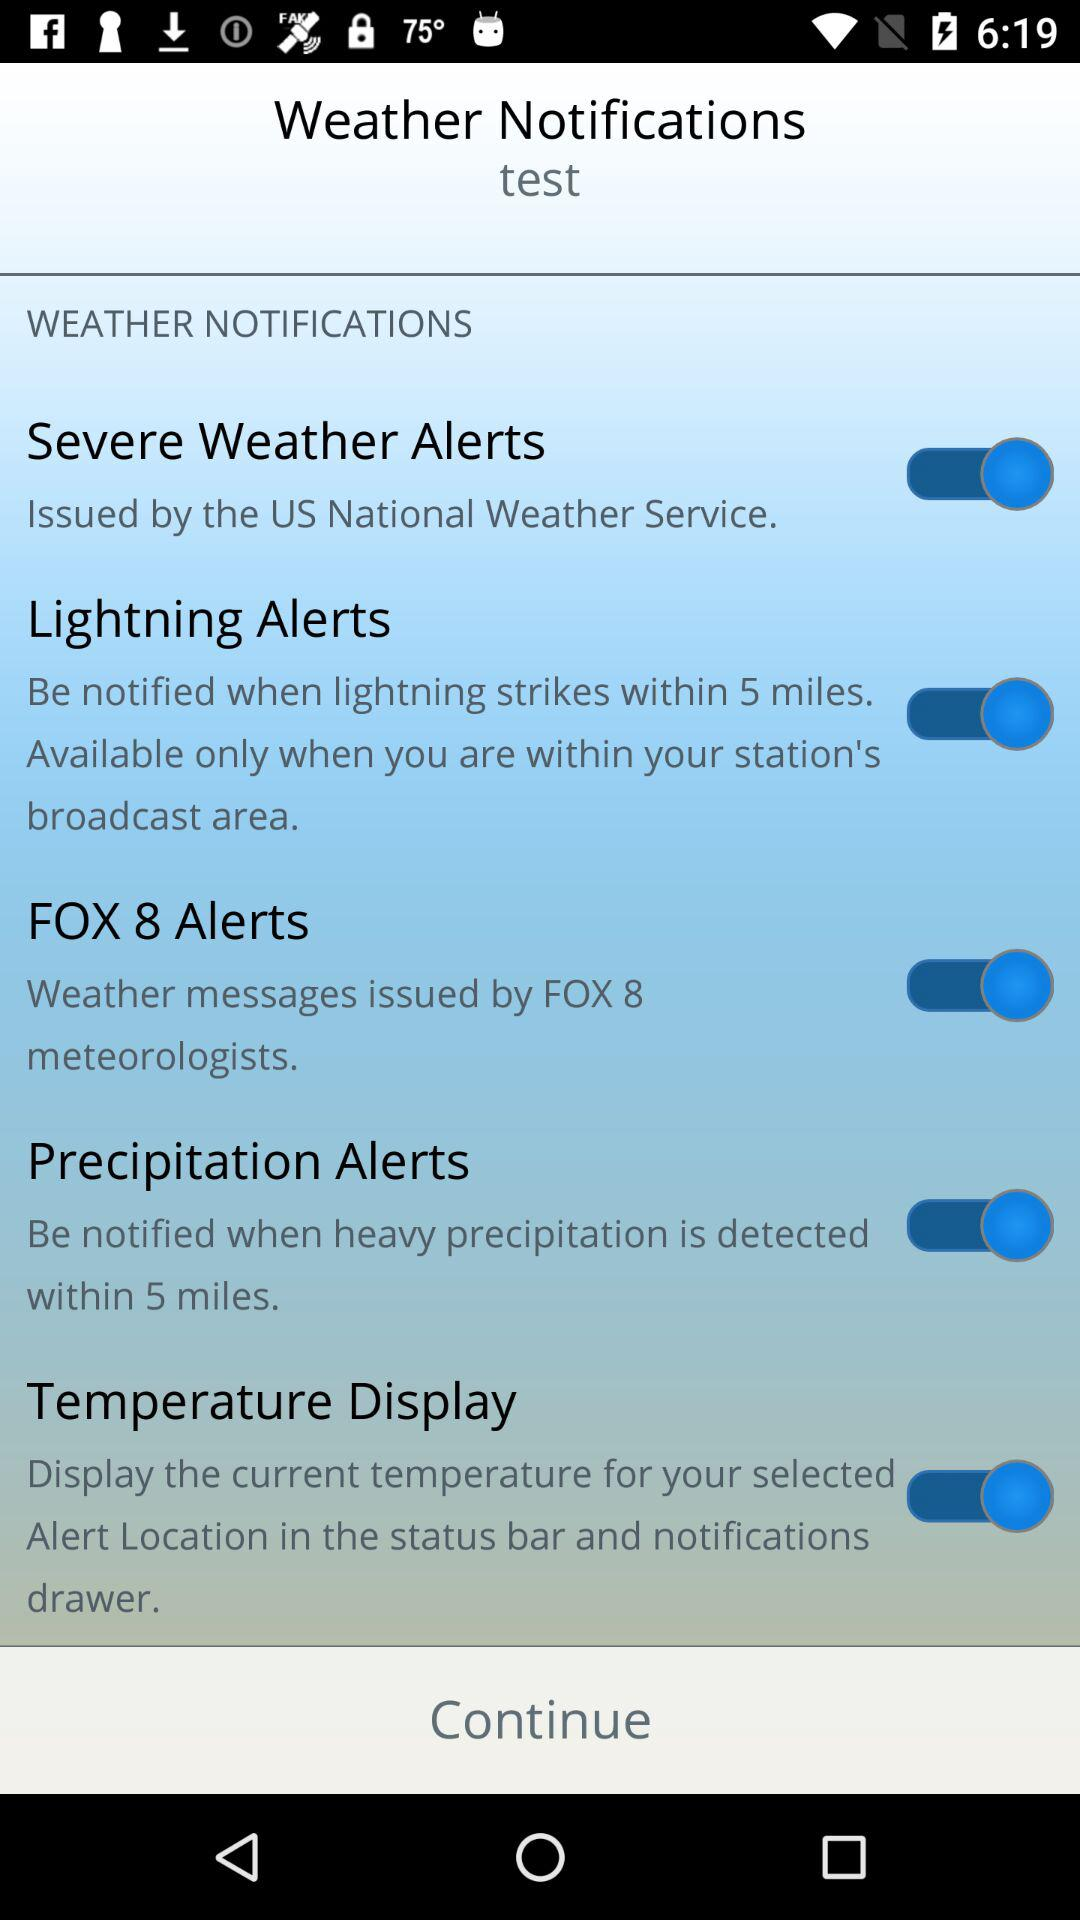Within how many miles will I be notified if there is heavy precipitation? You will be notified if there is heavy precipitation within 5 miles. 